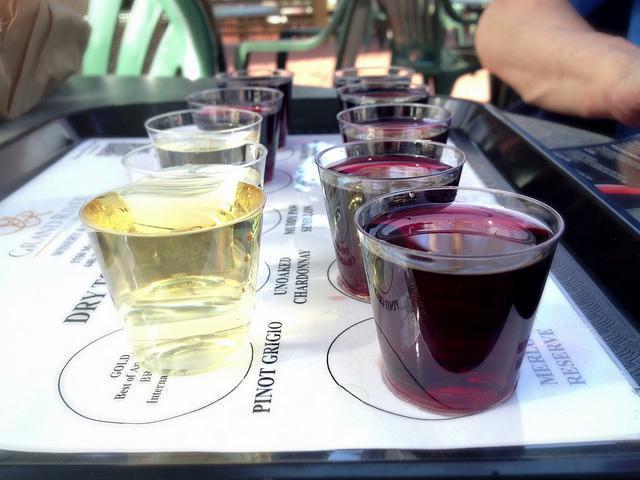What does the printing on the mat indicate?
Indicate the correct choice and explain in the format: 'Answer: answer
Rationale: rationale.'
Options: Wine varieties, names, people locations, destination. Answer: wine varieties.
Rationale: There are different glasses of wine on the respective places of the mat. 